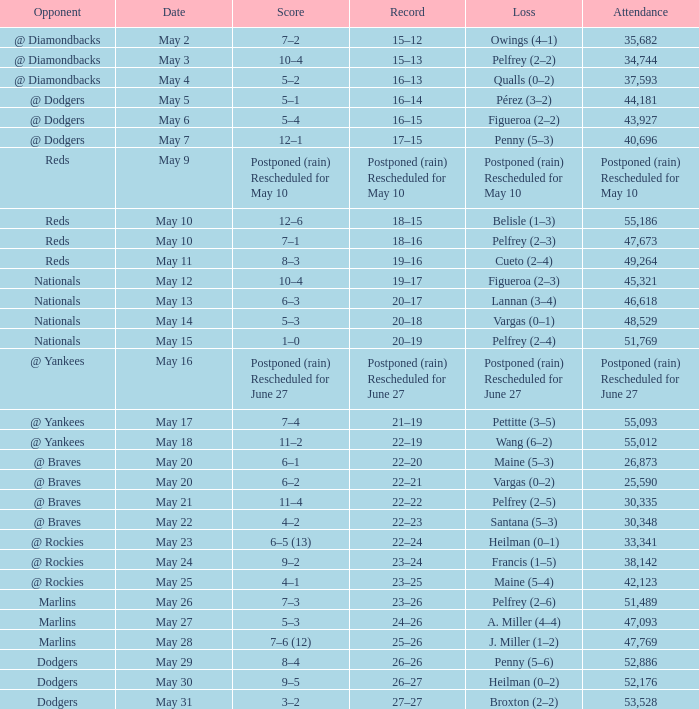Score of postponed (rain) rescheduled for June 27 had what loss? Postponed (rain) Rescheduled for June 27. 